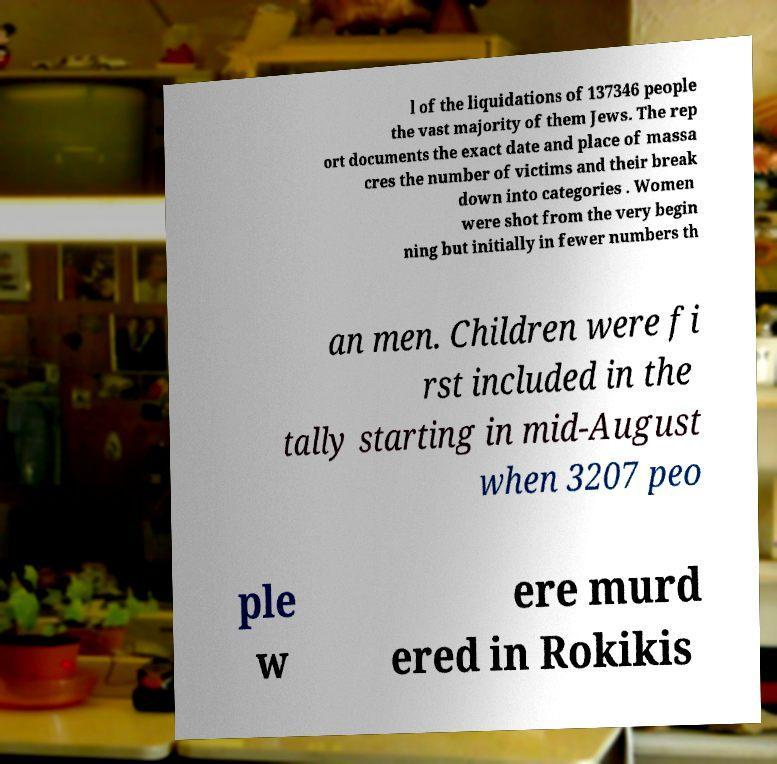Please identify and transcribe the text found in this image. l of the liquidations of 137346 people the vast majority of them Jews. The rep ort documents the exact date and place of massa cres the number of victims and their break down into categories . Women were shot from the very begin ning but initially in fewer numbers th an men. Children were fi rst included in the tally starting in mid-August when 3207 peo ple w ere murd ered in Rokikis 